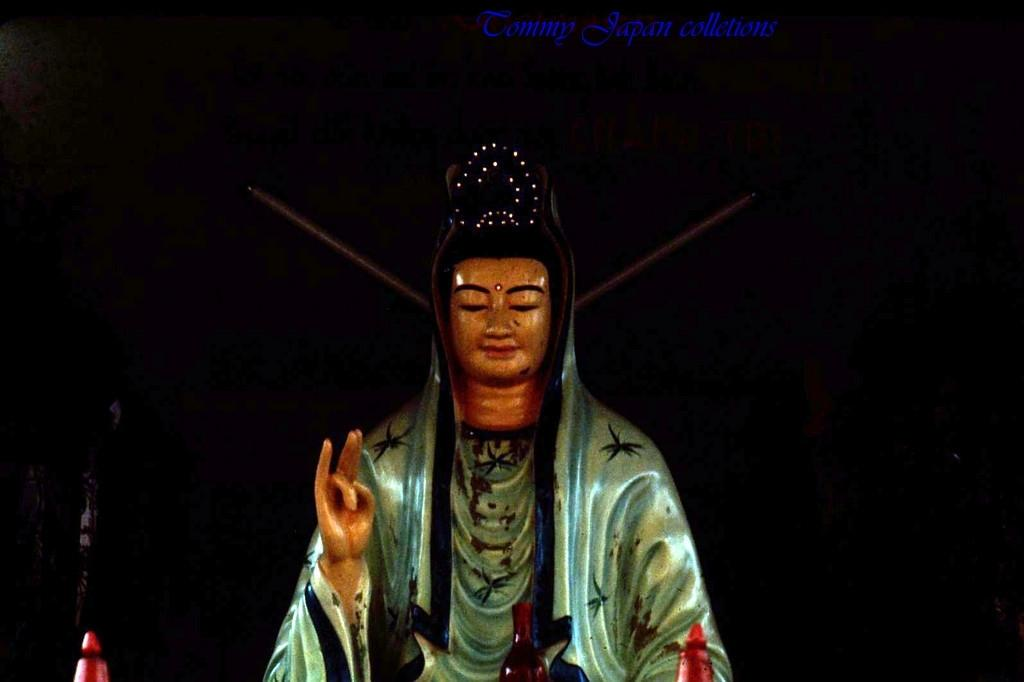What is the main subject of the image? The main subject of the image is a statue. Can you describe the background of the statue? The background of the statue is dark. What type of joke is the statue telling in the image? There is no indication in the image that the statue is telling a joke, as statues are typically not capable of telling jokes. 